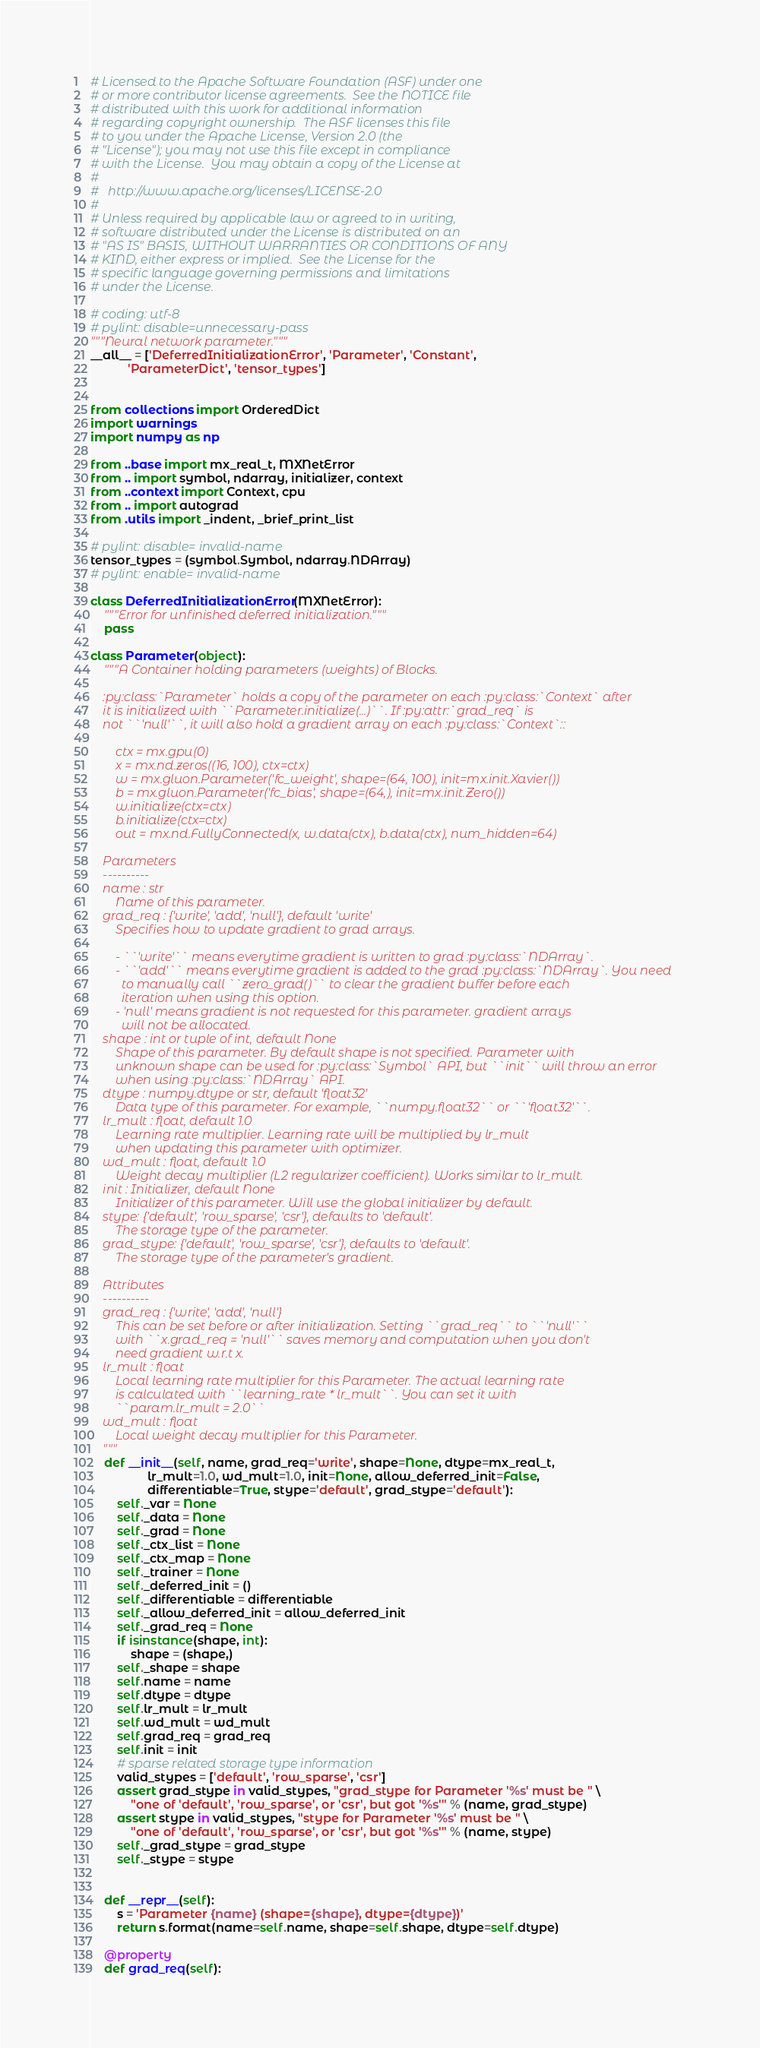Convert code to text. <code><loc_0><loc_0><loc_500><loc_500><_Python_># Licensed to the Apache Software Foundation (ASF) under one
# or more contributor license agreements.  See the NOTICE file
# distributed with this work for additional information
# regarding copyright ownership.  The ASF licenses this file
# to you under the Apache License, Version 2.0 (the
# "License"); you may not use this file except in compliance
# with the License.  You may obtain a copy of the License at
#
#   http://www.apache.org/licenses/LICENSE-2.0
#
# Unless required by applicable law or agreed to in writing,
# software distributed under the License is distributed on an
# "AS IS" BASIS, WITHOUT WARRANTIES OR CONDITIONS OF ANY
# KIND, either express or implied.  See the License for the
# specific language governing permissions and limitations
# under the License.

# coding: utf-8
# pylint: disable=unnecessary-pass
"""Neural network parameter."""
__all__ = ['DeferredInitializationError', 'Parameter', 'Constant',
           'ParameterDict', 'tensor_types']


from collections import OrderedDict
import warnings
import numpy as np

from ..base import mx_real_t, MXNetError
from .. import symbol, ndarray, initializer, context
from ..context import Context, cpu
from .. import autograd
from .utils import _indent, _brief_print_list

# pylint: disable= invalid-name
tensor_types = (symbol.Symbol, ndarray.NDArray)
# pylint: enable= invalid-name

class DeferredInitializationError(MXNetError):
    """Error for unfinished deferred initialization."""
    pass

class Parameter(object):
    """A Container holding parameters (weights) of Blocks.

    :py:class:`Parameter` holds a copy of the parameter on each :py:class:`Context` after
    it is initialized with ``Parameter.initialize(...)``. If :py:attr:`grad_req` is
    not ``'null'``, it will also hold a gradient array on each :py:class:`Context`::

        ctx = mx.gpu(0)
        x = mx.nd.zeros((16, 100), ctx=ctx)
        w = mx.gluon.Parameter('fc_weight', shape=(64, 100), init=mx.init.Xavier())
        b = mx.gluon.Parameter('fc_bias', shape=(64,), init=mx.init.Zero())
        w.initialize(ctx=ctx)
        b.initialize(ctx=ctx)
        out = mx.nd.FullyConnected(x, w.data(ctx), b.data(ctx), num_hidden=64)

    Parameters
    ----------
    name : str
        Name of this parameter.
    grad_req : {'write', 'add', 'null'}, default 'write'
        Specifies how to update gradient to grad arrays.

        - ``'write'`` means everytime gradient is written to grad :py:class:`NDArray`.
        - ``'add'`` means everytime gradient is added to the grad :py:class:`NDArray`. You need
          to manually call ``zero_grad()`` to clear the gradient buffer before each
          iteration when using this option.
        - 'null' means gradient is not requested for this parameter. gradient arrays
          will not be allocated.
    shape : int or tuple of int, default None
        Shape of this parameter. By default shape is not specified. Parameter with
        unknown shape can be used for :py:class:`Symbol` API, but ``init`` will throw an error
        when using :py:class:`NDArray` API.
    dtype : numpy.dtype or str, default 'float32'
        Data type of this parameter. For example, ``numpy.float32`` or ``'float32'``.
    lr_mult : float, default 1.0
        Learning rate multiplier. Learning rate will be multiplied by lr_mult
        when updating this parameter with optimizer.
    wd_mult : float, default 1.0
        Weight decay multiplier (L2 regularizer coefficient). Works similar to lr_mult.
    init : Initializer, default None
        Initializer of this parameter. Will use the global initializer by default.
    stype: {'default', 'row_sparse', 'csr'}, defaults to 'default'.
        The storage type of the parameter.
    grad_stype: {'default', 'row_sparse', 'csr'}, defaults to 'default'.
        The storage type of the parameter's gradient.

    Attributes
    ----------
    grad_req : {'write', 'add', 'null'}
        This can be set before or after initialization. Setting ``grad_req`` to ``'null'``
        with ``x.grad_req = 'null'`` saves memory and computation when you don't
        need gradient w.r.t x.
    lr_mult : float
        Local learning rate multiplier for this Parameter. The actual learning rate
        is calculated with ``learning_rate * lr_mult``. You can set it with
        ``param.lr_mult = 2.0``
    wd_mult : float
        Local weight decay multiplier for this Parameter.
    """
    def __init__(self, name, grad_req='write', shape=None, dtype=mx_real_t,
                 lr_mult=1.0, wd_mult=1.0, init=None, allow_deferred_init=False,
                 differentiable=True, stype='default', grad_stype='default'):
        self._var = None
        self._data = None
        self._grad = None
        self._ctx_list = None
        self._ctx_map = None
        self._trainer = None
        self._deferred_init = ()
        self._differentiable = differentiable
        self._allow_deferred_init = allow_deferred_init
        self._grad_req = None
        if isinstance(shape, int):
            shape = (shape,)
        self._shape = shape
        self.name = name
        self.dtype = dtype
        self.lr_mult = lr_mult
        self.wd_mult = wd_mult
        self.grad_req = grad_req
        self.init = init
        # sparse related storage type information
        valid_stypes = ['default', 'row_sparse', 'csr']
        assert grad_stype in valid_stypes, "grad_stype for Parameter '%s' must be " \
            "one of 'default', 'row_sparse', or 'csr', but got '%s'" % (name, grad_stype)
        assert stype in valid_stypes, "stype for Parameter '%s' must be " \
            "one of 'default', 'row_sparse', or 'csr', but got '%s'" % (name, stype)
        self._grad_stype = grad_stype
        self._stype = stype


    def __repr__(self):
        s = 'Parameter {name} (shape={shape}, dtype={dtype})'
        return s.format(name=self.name, shape=self.shape, dtype=self.dtype)

    @property
    def grad_req(self):</code> 